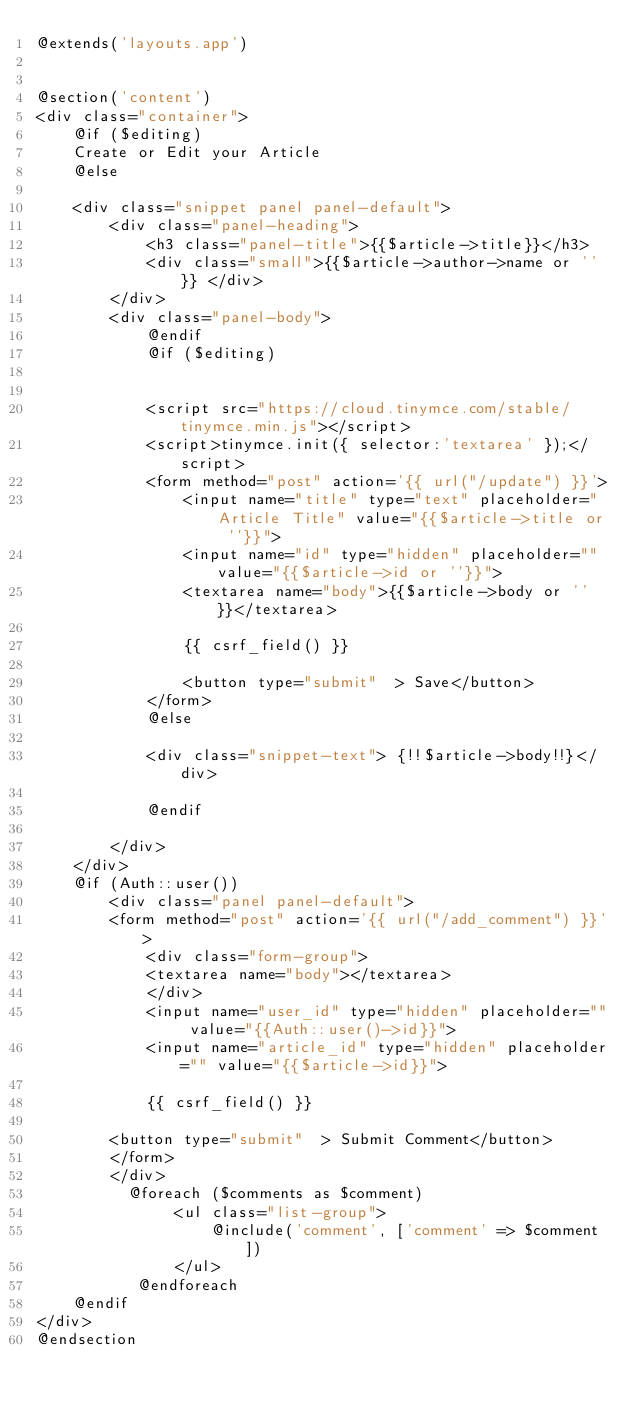Convert code to text. <code><loc_0><loc_0><loc_500><loc_500><_PHP_>@extends('layouts.app')


@section('content')
<div class="container">
	@if ($editing)
	Create or Edit your Article
	@else

	<div class="snippet panel panel-default">
		<div class="panel-heading">
			<h3 class="panel-title">{{$article->title}}</h3>
			<div class="small">{{$article->author->name or ''}} </div>
		</div>
		<div class="panel-body">
			@endif
			@if ($editing)


			<script src="https://cloud.tinymce.com/stable/tinymce.min.js"></script>
			<script>tinymce.init({ selector:'textarea' });</script>
			<form method="post" action='{{ url("/update") }}'>
				<input name="title" type="text" placeholder="Article Title" value="{{$article->title or ''}}">
				<input name="id" type="hidden" placeholder="" value="{{$article->id or ''}}">
				<textarea name="body">{{$article->body or ''}}</textarea>

				{{ csrf_field() }}

				<button type="submit"  > Save</button>
			</form>
			@else

			<div class="snippet-text"> {!!$article->body!!}</div>

			@endif

		</div>
	</div>
	@if (Auth::user())
		<div class="panel panel-default">
		<form method="post" action='{{ url("/add_comment") }}'>
			<div class="form-group">
			<textarea name="body"></textarea>
			</div>
			<input name="user_id" type="hidden" placeholder="" value="{{Auth::user()->id}}">
			<input name="article_id" type="hidden" placeholder="" value="{{$article->id}}">

			{{ csrf_field() }}

		<button type="submit"  > Submit Comment</button>
		</form>
		</div>
		  @foreach ($comments as $comment)
			   <ul class="list-group">
			       @include('comment', ['comment' => $comment])
			   </ul>
		   @endforeach
	@endif
</div>
@endsection


</code> 